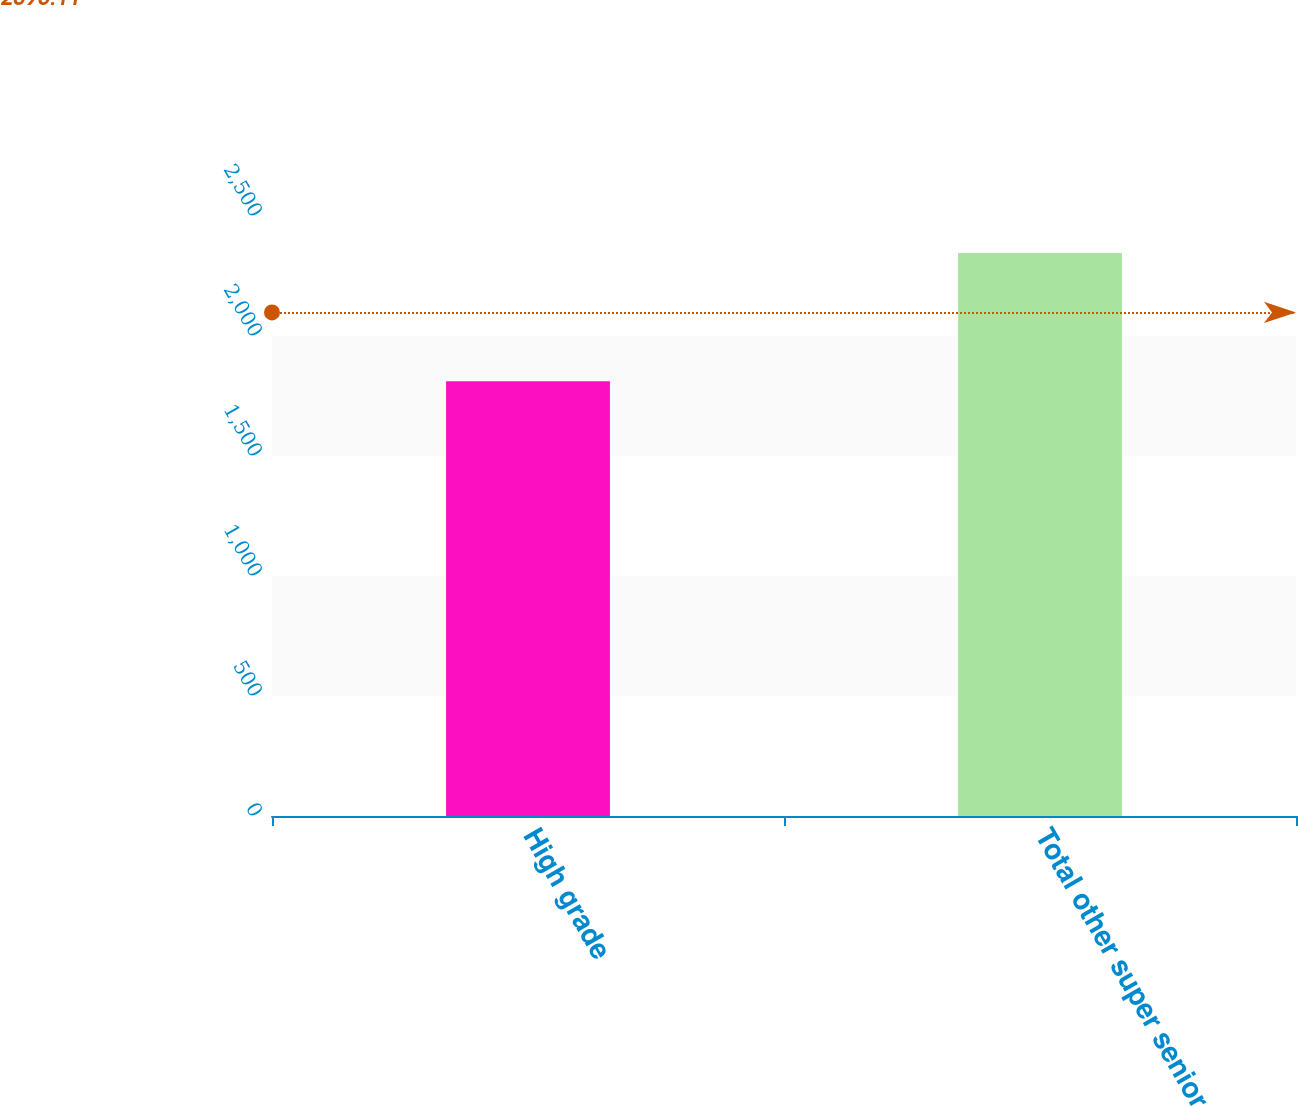<chart> <loc_0><loc_0><loc_500><loc_500><bar_chart><fcel>High grade<fcel>Total other super senior<nl><fcel>1811<fcel>2346<nl></chart> 